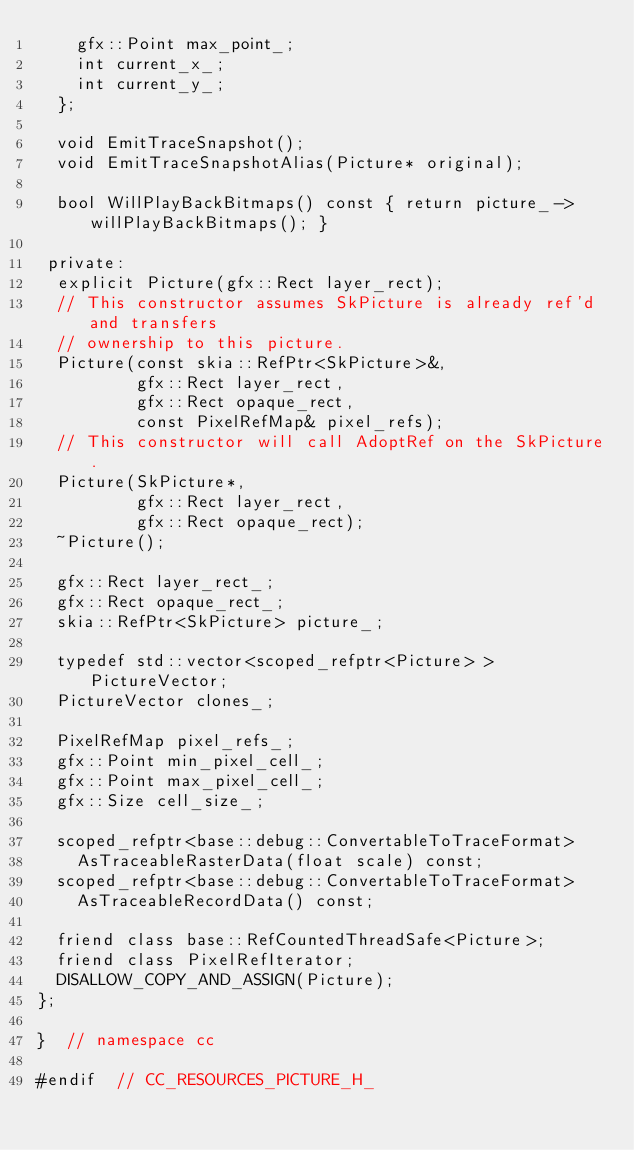<code> <loc_0><loc_0><loc_500><loc_500><_C_>    gfx::Point max_point_;
    int current_x_;
    int current_y_;
  };

  void EmitTraceSnapshot();
  void EmitTraceSnapshotAlias(Picture* original);

  bool WillPlayBackBitmaps() const { return picture_->willPlayBackBitmaps(); }

 private:
  explicit Picture(gfx::Rect layer_rect);
  // This constructor assumes SkPicture is already ref'd and transfers
  // ownership to this picture.
  Picture(const skia::RefPtr<SkPicture>&,
          gfx::Rect layer_rect,
          gfx::Rect opaque_rect,
          const PixelRefMap& pixel_refs);
  // This constructor will call AdoptRef on the SkPicture.
  Picture(SkPicture*,
          gfx::Rect layer_rect,
          gfx::Rect opaque_rect);
  ~Picture();

  gfx::Rect layer_rect_;
  gfx::Rect opaque_rect_;
  skia::RefPtr<SkPicture> picture_;

  typedef std::vector<scoped_refptr<Picture> > PictureVector;
  PictureVector clones_;

  PixelRefMap pixel_refs_;
  gfx::Point min_pixel_cell_;
  gfx::Point max_pixel_cell_;
  gfx::Size cell_size_;

  scoped_refptr<base::debug::ConvertableToTraceFormat>
    AsTraceableRasterData(float scale) const;
  scoped_refptr<base::debug::ConvertableToTraceFormat>
    AsTraceableRecordData() const;

  friend class base::RefCountedThreadSafe<Picture>;
  friend class PixelRefIterator;
  DISALLOW_COPY_AND_ASSIGN(Picture);
};

}  // namespace cc

#endif  // CC_RESOURCES_PICTURE_H_
</code> 